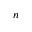<formula> <loc_0><loc_0><loc_500><loc_500>n</formula> 